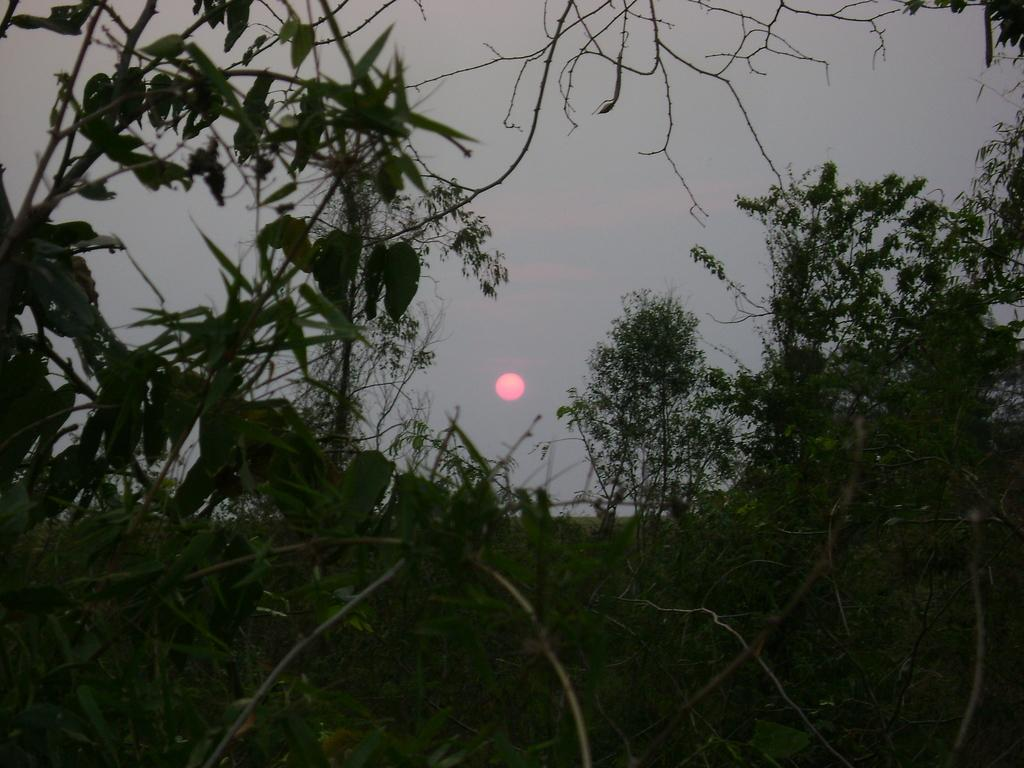What type of vegetation can be seen in the image? There are trees in the image. Where are the trees located in relation to the rest of the image? The trees are located in the background. What celestial body is visible in the image? The sun is visible in the image. What is the color of the sun in the image? The sun appears to be red in color. How does the knot in the tree trunk affect the profit of the nearby business in the image? There is no knot in the tree trunk, nor is there any mention of a nearby business in the image. 